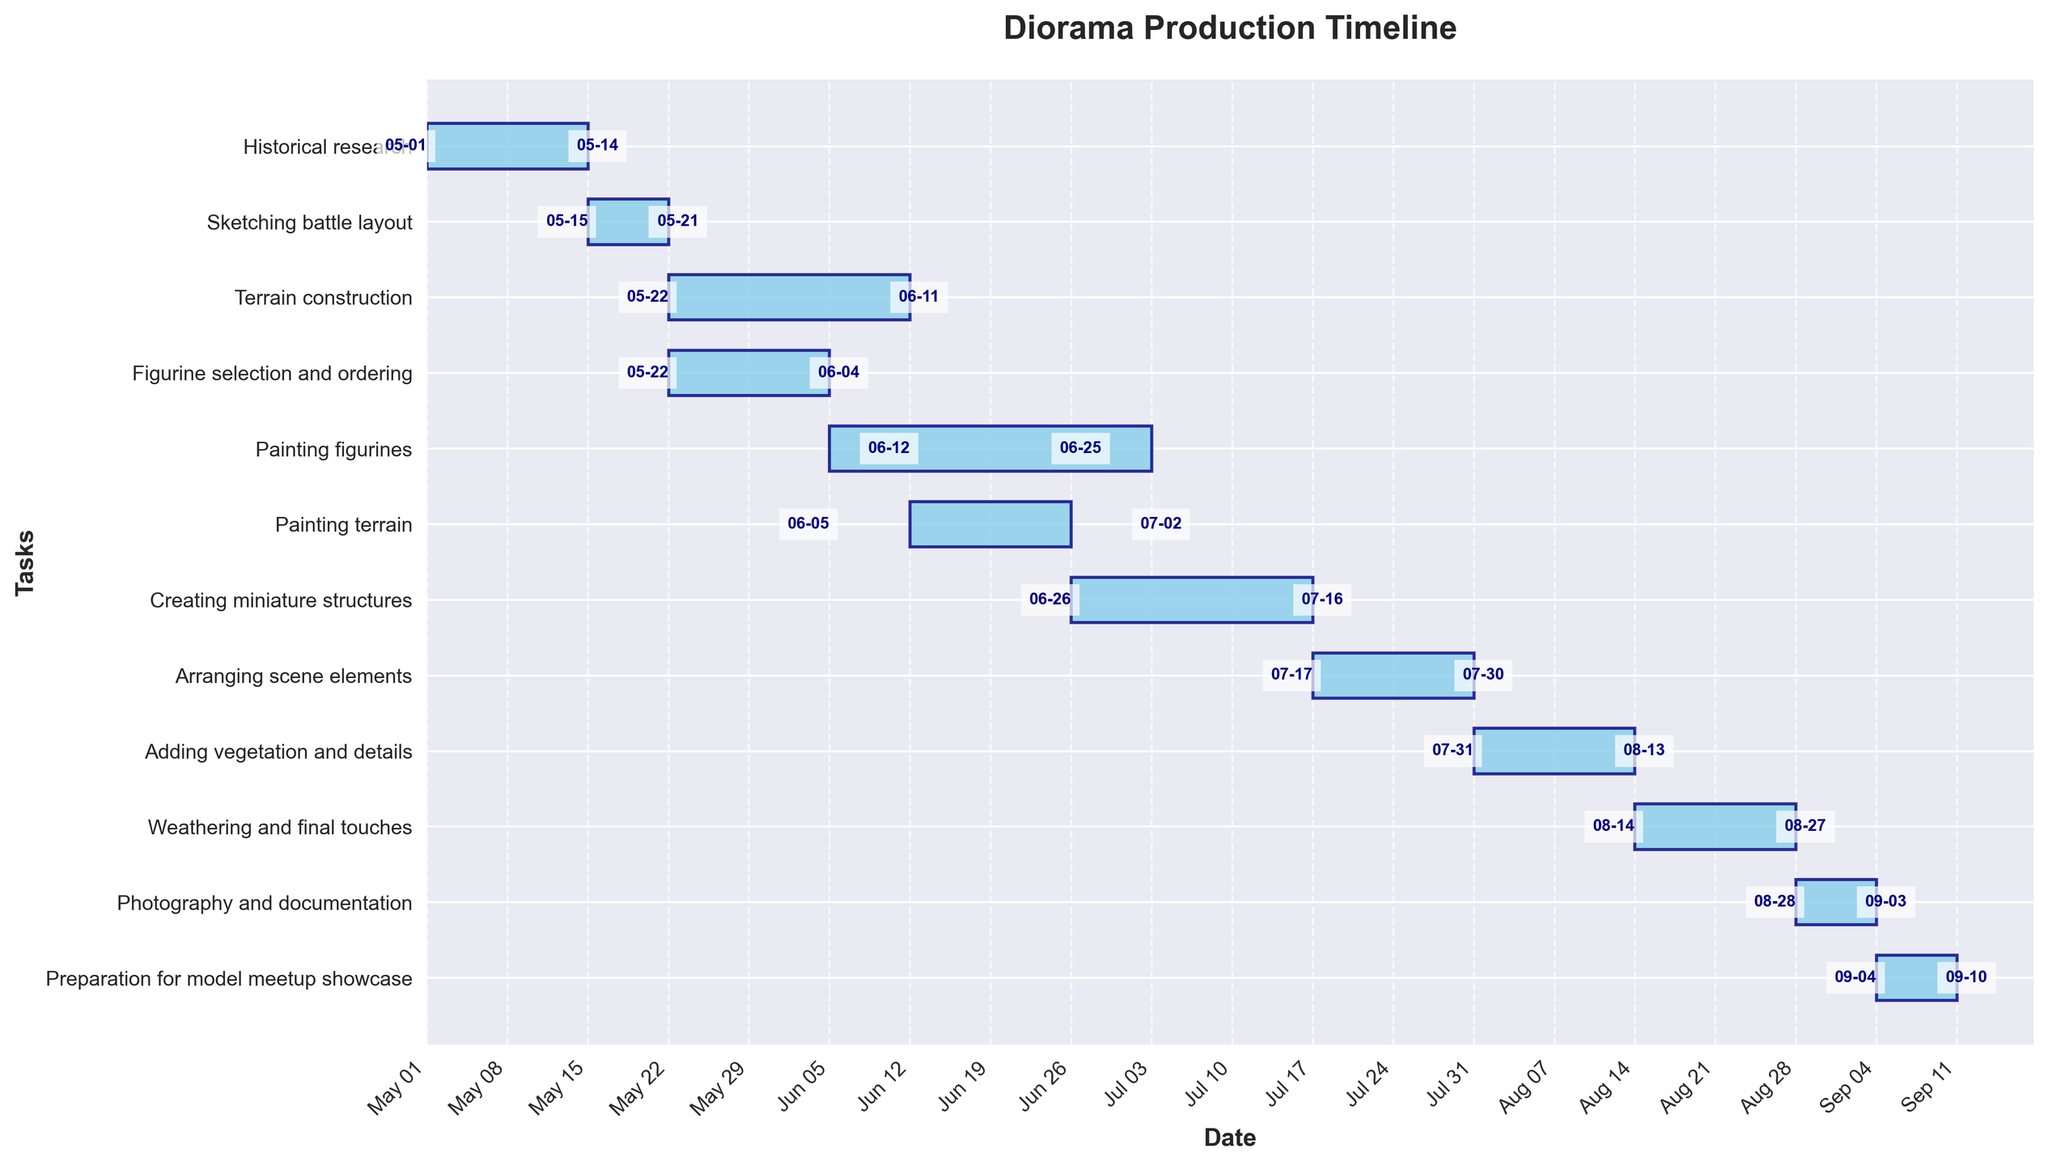What is the title of the Gantt Chart? The title of any chart is typically located at the top center and it provides an overview of what the chart is about. In this case, it informs us that the chart is about the production timeline for a diorama.
Answer: Diorama Production Timeline What is the duration of the 'Sketching battle layout' task? To determine the duration of a task, compare its start date with its end date. 'Sketching battle layout' starts on May 15, 2023, and ends on May 21, 2023. The duration is calculated by counting the number of days from the start to the end date.
Answer: 7 days Which task starts first and which one starts last? To find the first and last tasks, look at the starting dates of each task. The task with the earliest start date begins first, and the task with the latest start date begins last. 'Historical research' starts on May 1, 2023, and 'Preparation for model meetup showcase' starts on September 4, 2023.
Answer: Historical research (first), Preparation for model meetup showcase (last) How many tasks are running concurrently during the week of June 5, 2023? To identify concurrent tasks, check the timelines and see which tasks overlap during the specified week. 'Terrain construction', 'Figurine selection and ordering', 'Painting terrain', 'Painting figurines' are all active during this week.
Answer: 3 tasks Which task has the longest duration? By comparing the durations of all tasks, find the one with the maximum duration. 'Painting figurines' starts on June 5, 2023, and ends on July 2, 2023, lasting for 28 days, making it the longest task.
Answer: Painting figurines What tasks are involved in the month of July 2023? To find tasks that are active in a particular month, check their timelines. 'Painting figurines', 'Creating miniature structures', 'Arranging scene elements', and 'Adding vegetation and details' all occur in July 2023.
Answer: Painting figurines, Creating miniature structures, Arranging scene elements, Adding vegetation and details During which task do the 'Creating miniature structures' start and end dates fall? To find overlapping tasks, compare the start and end dates of 'Creating miniature structures' with other tasks. It starts on June 26, 2023, during 'Painting figurines', and ends on July 16, 2023, during 'Arranging scene elements'.
Answer: Painting figurines (start), Arranging scene elements (end) What is the total duration for completing the entire production timeline from the start of the first task to the end of the last task? Calculate the total duration by finding the difference between the start date of the first task and the end date of the last task. 'Historical research' starts on May 1, 2023, and 'Preparation for model meetup showcase' ends on September 10, 2023. This period spans 133 days.
Answer: 133 days 